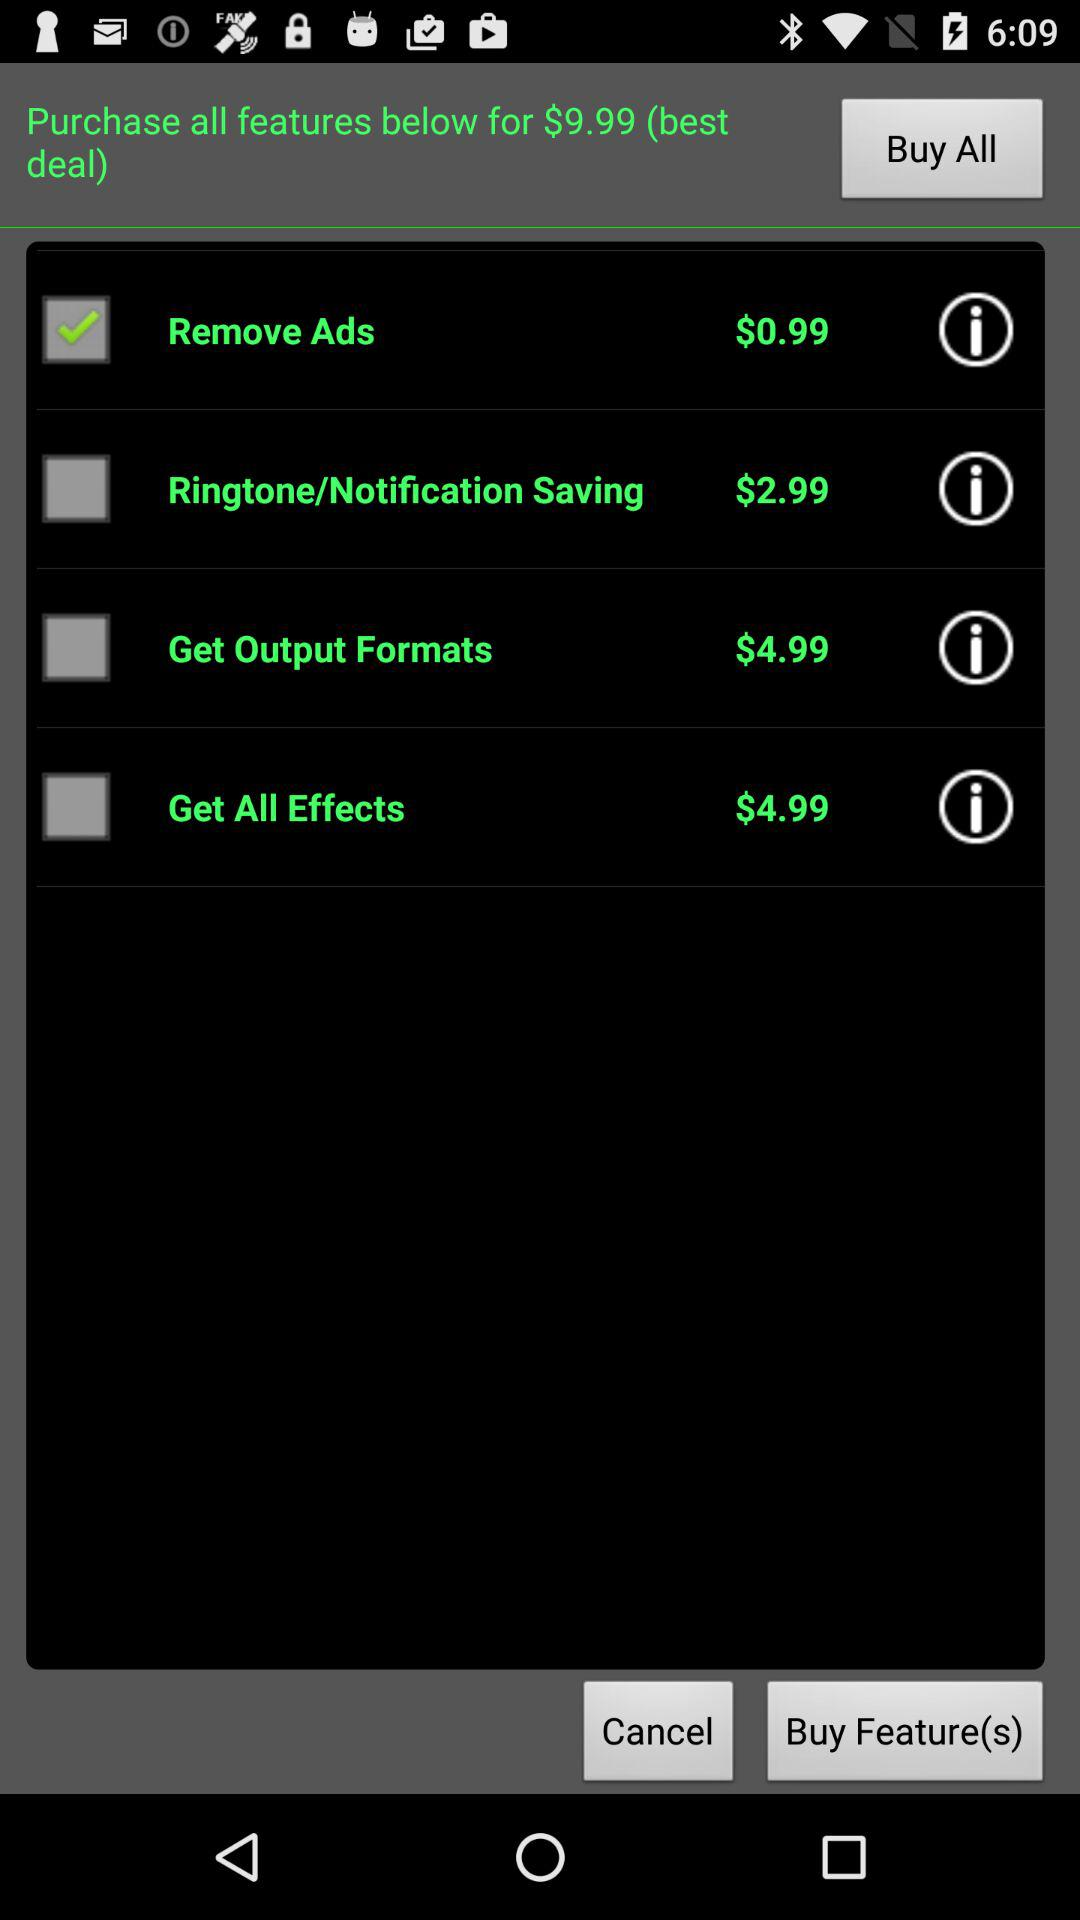What is the best deal to purchase all the features? The best deal to purchase all features is $9.99. 